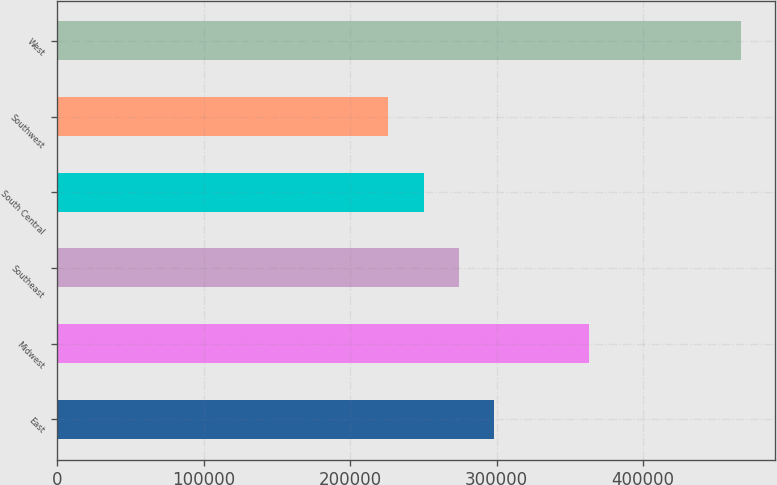Convert chart. <chart><loc_0><loc_0><loc_500><loc_500><bar_chart><fcel>East<fcel>Midwest<fcel>Southeast<fcel>South Central<fcel>Southwest<fcel>West<nl><fcel>298200<fcel>363000<fcel>274100<fcel>250000<fcel>225900<fcel>466900<nl></chart> 